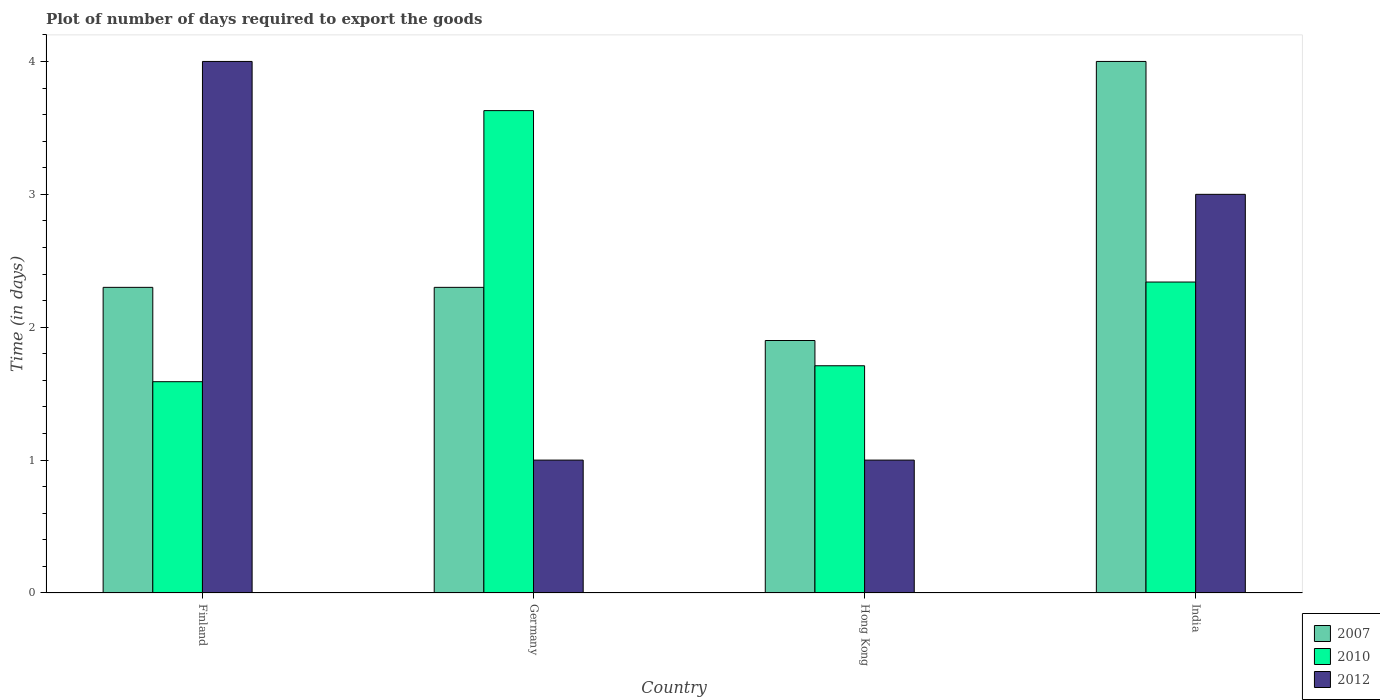How many different coloured bars are there?
Your answer should be compact. 3. Are the number of bars per tick equal to the number of legend labels?
Offer a terse response. Yes. How many bars are there on the 3rd tick from the left?
Keep it short and to the point. 3. What is the time required to export goods in 2010 in Germany?
Provide a short and direct response. 3.63. Across all countries, what is the maximum time required to export goods in 2010?
Ensure brevity in your answer.  3.63. Across all countries, what is the minimum time required to export goods in 2010?
Offer a terse response. 1.59. In which country was the time required to export goods in 2012 minimum?
Keep it short and to the point. Germany. What is the total time required to export goods in 2010 in the graph?
Offer a terse response. 9.27. What is the difference between the time required to export goods in 2010 in Hong Kong and that in India?
Your response must be concise. -0.63. What is the difference between the time required to export goods in 2007 in Finland and the time required to export goods in 2010 in Hong Kong?
Offer a very short reply. 0.59. What is the average time required to export goods in 2012 per country?
Ensure brevity in your answer.  2.25. What is the difference between the time required to export goods of/in 2007 and time required to export goods of/in 2010 in Germany?
Your response must be concise. -1.33. In how many countries, is the time required to export goods in 2010 greater than 2.4 days?
Your response must be concise. 1. Is the time required to export goods in 2007 in Finland less than that in India?
Offer a terse response. Yes. What is the difference between the highest and the second highest time required to export goods in 2010?
Your answer should be very brief. -0.63. In how many countries, is the time required to export goods in 2007 greater than the average time required to export goods in 2007 taken over all countries?
Ensure brevity in your answer.  1. Is the sum of the time required to export goods in 2007 in Germany and Hong Kong greater than the maximum time required to export goods in 2010 across all countries?
Provide a short and direct response. Yes. What does the 1st bar from the left in Finland represents?
Keep it short and to the point. 2007. Is it the case that in every country, the sum of the time required to export goods in 2007 and time required to export goods in 2012 is greater than the time required to export goods in 2010?
Offer a terse response. No. How many bars are there?
Offer a very short reply. 12. Are all the bars in the graph horizontal?
Ensure brevity in your answer.  No. What is the difference between two consecutive major ticks on the Y-axis?
Keep it short and to the point. 1. Are the values on the major ticks of Y-axis written in scientific E-notation?
Your response must be concise. No. Does the graph contain any zero values?
Provide a short and direct response. No. How many legend labels are there?
Provide a short and direct response. 3. What is the title of the graph?
Offer a very short reply. Plot of number of days required to export the goods. What is the label or title of the Y-axis?
Offer a very short reply. Time (in days). What is the Time (in days) in 2007 in Finland?
Provide a short and direct response. 2.3. What is the Time (in days) of 2010 in Finland?
Your answer should be very brief. 1.59. What is the Time (in days) in 2012 in Finland?
Provide a succinct answer. 4. What is the Time (in days) of 2010 in Germany?
Ensure brevity in your answer.  3.63. What is the Time (in days) in 2012 in Germany?
Your response must be concise. 1. What is the Time (in days) in 2010 in Hong Kong?
Provide a succinct answer. 1.71. What is the Time (in days) in 2012 in Hong Kong?
Give a very brief answer. 1. What is the Time (in days) of 2007 in India?
Keep it short and to the point. 4. What is the Time (in days) in 2010 in India?
Your response must be concise. 2.34. Across all countries, what is the maximum Time (in days) of 2007?
Your answer should be very brief. 4. Across all countries, what is the maximum Time (in days) of 2010?
Make the answer very short. 3.63. Across all countries, what is the minimum Time (in days) of 2010?
Offer a terse response. 1.59. Across all countries, what is the minimum Time (in days) in 2012?
Offer a terse response. 1. What is the total Time (in days) in 2007 in the graph?
Your answer should be compact. 10.5. What is the total Time (in days) of 2010 in the graph?
Your response must be concise. 9.27. What is the total Time (in days) in 2012 in the graph?
Your answer should be very brief. 9. What is the difference between the Time (in days) of 2007 in Finland and that in Germany?
Provide a short and direct response. 0. What is the difference between the Time (in days) of 2010 in Finland and that in Germany?
Offer a terse response. -2.04. What is the difference between the Time (in days) in 2010 in Finland and that in Hong Kong?
Offer a very short reply. -0.12. What is the difference between the Time (in days) in 2010 in Finland and that in India?
Offer a terse response. -0.75. What is the difference between the Time (in days) in 2012 in Finland and that in India?
Make the answer very short. 1. What is the difference between the Time (in days) of 2010 in Germany and that in Hong Kong?
Offer a very short reply. 1.92. What is the difference between the Time (in days) in 2007 in Germany and that in India?
Provide a short and direct response. -1.7. What is the difference between the Time (in days) of 2010 in Germany and that in India?
Provide a succinct answer. 1.29. What is the difference between the Time (in days) in 2010 in Hong Kong and that in India?
Your answer should be compact. -0.63. What is the difference between the Time (in days) in 2007 in Finland and the Time (in days) in 2010 in Germany?
Ensure brevity in your answer.  -1.33. What is the difference between the Time (in days) in 2010 in Finland and the Time (in days) in 2012 in Germany?
Ensure brevity in your answer.  0.59. What is the difference between the Time (in days) in 2007 in Finland and the Time (in days) in 2010 in Hong Kong?
Your answer should be very brief. 0.59. What is the difference between the Time (in days) of 2010 in Finland and the Time (in days) of 2012 in Hong Kong?
Give a very brief answer. 0.59. What is the difference between the Time (in days) of 2007 in Finland and the Time (in days) of 2010 in India?
Make the answer very short. -0.04. What is the difference between the Time (in days) of 2010 in Finland and the Time (in days) of 2012 in India?
Your response must be concise. -1.41. What is the difference between the Time (in days) of 2007 in Germany and the Time (in days) of 2010 in Hong Kong?
Provide a short and direct response. 0.59. What is the difference between the Time (in days) of 2007 in Germany and the Time (in days) of 2012 in Hong Kong?
Ensure brevity in your answer.  1.3. What is the difference between the Time (in days) of 2010 in Germany and the Time (in days) of 2012 in Hong Kong?
Your answer should be very brief. 2.63. What is the difference between the Time (in days) of 2007 in Germany and the Time (in days) of 2010 in India?
Your response must be concise. -0.04. What is the difference between the Time (in days) in 2007 in Germany and the Time (in days) in 2012 in India?
Provide a succinct answer. -0.7. What is the difference between the Time (in days) in 2010 in Germany and the Time (in days) in 2012 in India?
Your response must be concise. 0.63. What is the difference between the Time (in days) in 2007 in Hong Kong and the Time (in days) in 2010 in India?
Offer a terse response. -0.44. What is the difference between the Time (in days) of 2010 in Hong Kong and the Time (in days) of 2012 in India?
Your answer should be compact. -1.29. What is the average Time (in days) in 2007 per country?
Provide a short and direct response. 2.62. What is the average Time (in days) in 2010 per country?
Offer a very short reply. 2.32. What is the average Time (in days) of 2012 per country?
Make the answer very short. 2.25. What is the difference between the Time (in days) of 2007 and Time (in days) of 2010 in Finland?
Make the answer very short. 0.71. What is the difference between the Time (in days) of 2010 and Time (in days) of 2012 in Finland?
Give a very brief answer. -2.41. What is the difference between the Time (in days) in 2007 and Time (in days) in 2010 in Germany?
Keep it short and to the point. -1.33. What is the difference between the Time (in days) in 2010 and Time (in days) in 2012 in Germany?
Your response must be concise. 2.63. What is the difference between the Time (in days) in 2007 and Time (in days) in 2010 in Hong Kong?
Give a very brief answer. 0.19. What is the difference between the Time (in days) of 2007 and Time (in days) of 2012 in Hong Kong?
Offer a terse response. 0.9. What is the difference between the Time (in days) of 2010 and Time (in days) of 2012 in Hong Kong?
Offer a terse response. 0.71. What is the difference between the Time (in days) of 2007 and Time (in days) of 2010 in India?
Offer a very short reply. 1.66. What is the difference between the Time (in days) in 2007 and Time (in days) in 2012 in India?
Provide a succinct answer. 1. What is the difference between the Time (in days) in 2010 and Time (in days) in 2012 in India?
Keep it short and to the point. -0.66. What is the ratio of the Time (in days) of 2010 in Finland to that in Germany?
Ensure brevity in your answer.  0.44. What is the ratio of the Time (in days) of 2012 in Finland to that in Germany?
Your answer should be compact. 4. What is the ratio of the Time (in days) of 2007 in Finland to that in Hong Kong?
Make the answer very short. 1.21. What is the ratio of the Time (in days) in 2010 in Finland to that in Hong Kong?
Give a very brief answer. 0.93. What is the ratio of the Time (in days) in 2007 in Finland to that in India?
Ensure brevity in your answer.  0.57. What is the ratio of the Time (in days) in 2010 in Finland to that in India?
Your answer should be very brief. 0.68. What is the ratio of the Time (in days) in 2007 in Germany to that in Hong Kong?
Offer a very short reply. 1.21. What is the ratio of the Time (in days) of 2010 in Germany to that in Hong Kong?
Give a very brief answer. 2.12. What is the ratio of the Time (in days) of 2007 in Germany to that in India?
Ensure brevity in your answer.  0.57. What is the ratio of the Time (in days) in 2010 in Germany to that in India?
Offer a very short reply. 1.55. What is the ratio of the Time (in days) of 2007 in Hong Kong to that in India?
Your answer should be compact. 0.47. What is the ratio of the Time (in days) of 2010 in Hong Kong to that in India?
Your answer should be very brief. 0.73. What is the difference between the highest and the second highest Time (in days) in 2010?
Provide a succinct answer. 1.29. What is the difference between the highest and the second highest Time (in days) of 2012?
Make the answer very short. 1. What is the difference between the highest and the lowest Time (in days) of 2010?
Your answer should be very brief. 2.04. What is the difference between the highest and the lowest Time (in days) of 2012?
Provide a short and direct response. 3. 